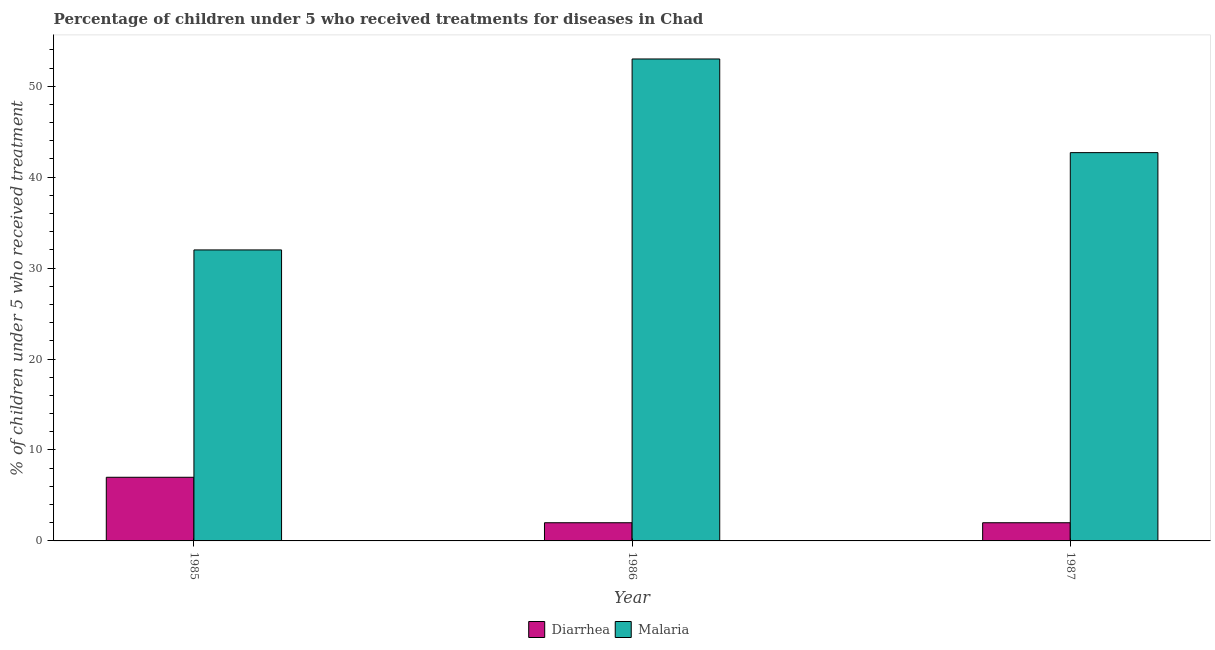How many groups of bars are there?
Keep it short and to the point. 3. Are the number of bars per tick equal to the number of legend labels?
Give a very brief answer. Yes. How many bars are there on the 1st tick from the left?
Provide a succinct answer. 2. How many bars are there on the 2nd tick from the right?
Your answer should be compact. 2. What is the label of the 2nd group of bars from the left?
Offer a very short reply. 1986. What is the percentage of children who received treatment for diarrhoea in 1987?
Offer a terse response. 2. Across all years, what is the maximum percentage of children who received treatment for diarrhoea?
Provide a succinct answer. 7. Across all years, what is the minimum percentage of children who received treatment for malaria?
Your answer should be very brief. 32. What is the total percentage of children who received treatment for malaria in the graph?
Make the answer very short. 127.7. What is the average percentage of children who received treatment for malaria per year?
Offer a very short reply. 42.57. In how many years, is the percentage of children who received treatment for diarrhoea greater than 44 %?
Provide a succinct answer. 0. What is the ratio of the percentage of children who received treatment for malaria in 1986 to that in 1987?
Your answer should be very brief. 1.24. Is the percentage of children who received treatment for malaria in 1985 less than that in 1987?
Offer a terse response. Yes. Is the difference between the percentage of children who received treatment for malaria in 1986 and 1987 greater than the difference between the percentage of children who received treatment for diarrhoea in 1986 and 1987?
Your answer should be compact. No. What is the difference between the highest and the second highest percentage of children who received treatment for malaria?
Your answer should be compact. 10.3. What is the difference between the highest and the lowest percentage of children who received treatment for diarrhoea?
Keep it short and to the point. 5. In how many years, is the percentage of children who received treatment for malaria greater than the average percentage of children who received treatment for malaria taken over all years?
Offer a terse response. 2. What does the 1st bar from the left in 1986 represents?
Make the answer very short. Diarrhea. What does the 1st bar from the right in 1987 represents?
Ensure brevity in your answer.  Malaria. How many bars are there?
Your answer should be very brief. 6. Are all the bars in the graph horizontal?
Provide a short and direct response. No. How many years are there in the graph?
Make the answer very short. 3. Are the values on the major ticks of Y-axis written in scientific E-notation?
Keep it short and to the point. No. Does the graph contain any zero values?
Provide a succinct answer. No. How are the legend labels stacked?
Provide a short and direct response. Horizontal. What is the title of the graph?
Your answer should be very brief. Percentage of children under 5 who received treatments for diseases in Chad. What is the label or title of the X-axis?
Your answer should be compact. Year. What is the label or title of the Y-axis?
Provide a short and direct response. % of children under 5 who received treatment. What is the % of children under 5 who received treatment of Malaria in 1985?
Offer a very short reply. 32. What is the % of children under 5 who received treatment in Diarrhea in 1986?
Ensure brevity in your answer.  2. What is the % of children under 5 who received treatment in Diarrhea in 1987?
Ensure brevity in your answer.  2. What is the % of children under 5 who received treatment in Malaria in 1987?
Offer a terse response. 42.7. Across all years, what is the maximum % of children under 5 who received treatment in Malaria?
Your answer should be compact. 53. What is the total % of children under 5 who received treatment in Malaria in the graph?
Your answer should be compact. 127.7. What is the difference between the % of children under 5 who received treatment in Diarrhea in 1985 and that in 1986?
Your response must be concise. 5. What is the difference between the % of children under 5 who received treatment of Malaria in 1985 and that in 1986?
Your answer should be compact. -21. What is the difference between the % of children under 5 who received treatment of Malaria in 1985 and that in 1987?
Your answer should be very brief. -10.7. What is the difference between the % of children under 5 who received treatment of Diarrhea in 1985 and the % of children under 5 who received treatment of Malaria in 1986?
Make the answer very short. -46. What is the difference between the % of children under 5 who received treatment in Diarrhea in 1985 and the % of children under 5 who received treatment in Malaria in 1987?
Make the answer very short. -35.7. What is the difference between the % of children under 5 who received treatment in Diarrhea in 1986 and the % of children under 5 who received treatment in Malaria in 1987?
Provide a succinct answer. -40.7. What is the average % of children under 5 who received treatment in Diarrhea per year?
Offer a very short reply. 3.67. What is the average % of children under 5 who received treatment of Malaria per year?
Offer a very short reply. 42.57. In the year 1985, what is the difference between the % of children under 5 who received treatment of Diarrhea and % of children under 5 who received treatment of Malaria?
Make the answer very short. -25. In the year 1986, what is the difference between the % of children under 5 who received treatment in Diarrhea and % of children under 5 who received treatment in Malaria?
Provide a succinct answer. -51. In the year 1987, what is the difference between the % of children under 5 who received treatment of Diarrhea and % of children under 5 who received treatment of Malaria?
Your response must be concise. -40.7. What is the ratio of the % of children under 5 who received treatment of Diarrhea in 1985 to that in 1986?
Give a very brief answer. 3.5. What is the ratio of the % of children under 5 who received treatment of Malaria in 1985 to that in 1986?
Make the answer very short. 0.6. What is the ratio of the % of children under 5 who received treatment of Diarrhea in 1985 to that in 1987?
Offer a very short reply. 3.5. What is the ratio of the % of children under 5 who received treatment of Malaria in 1985 to that in 1987?
Your answer should be very brief. 0.75. What is the ratio of the % of children under 5 who received treatment in Malaria in 1986 to that in 1987?
Offer a very short reply. 1.24. What is the difference between the highest and the second highest % of children under 5 who received treatment in Diarrhea?
Ensure brevity in your answer.  5. What is the difference between the highest and the second highest % of children under 5 who received treatment in Malaria?
Your answer should be very brief. 10.3. What is the difference between the highest and the lowest % of children under 5 who received treatment in Malaria?
Your response must be concise. 21. 